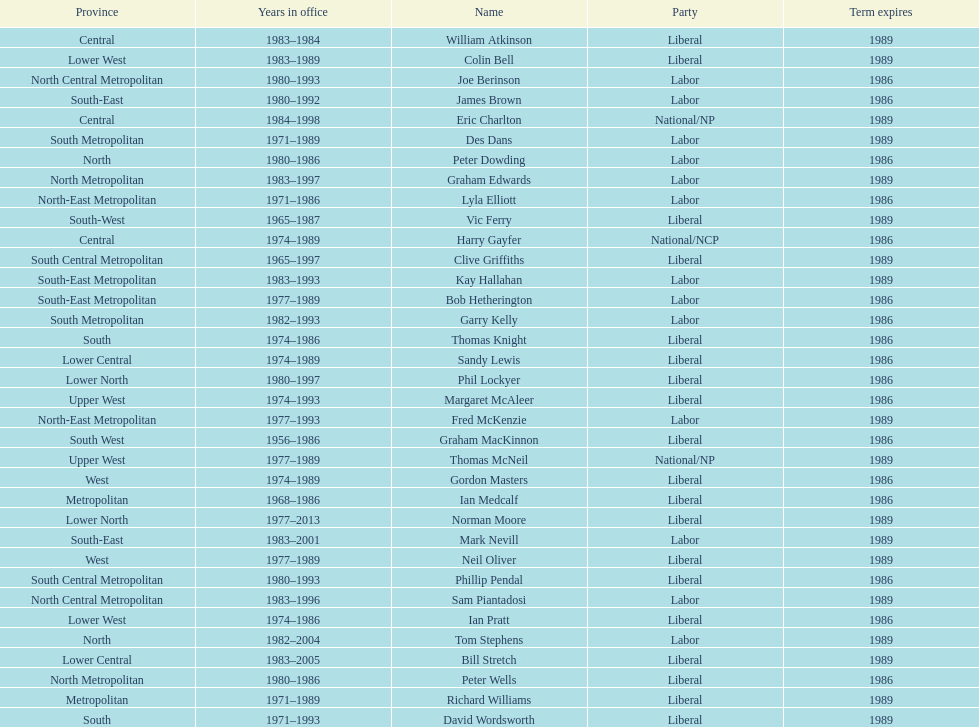What was phil lockyer's party? Liberal. 